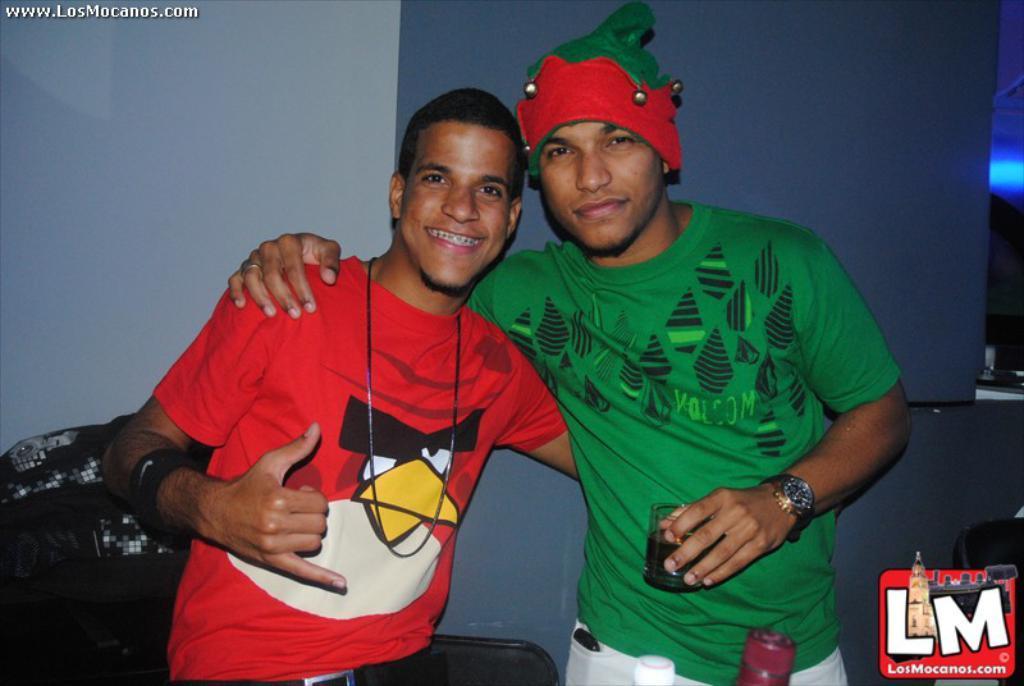Could you give a brief overview of what you see in this image? In this picture we can see there are two men standing. A man is holding a glass. Behind the men, there is an object and the wall. On the image there are watermarks. 